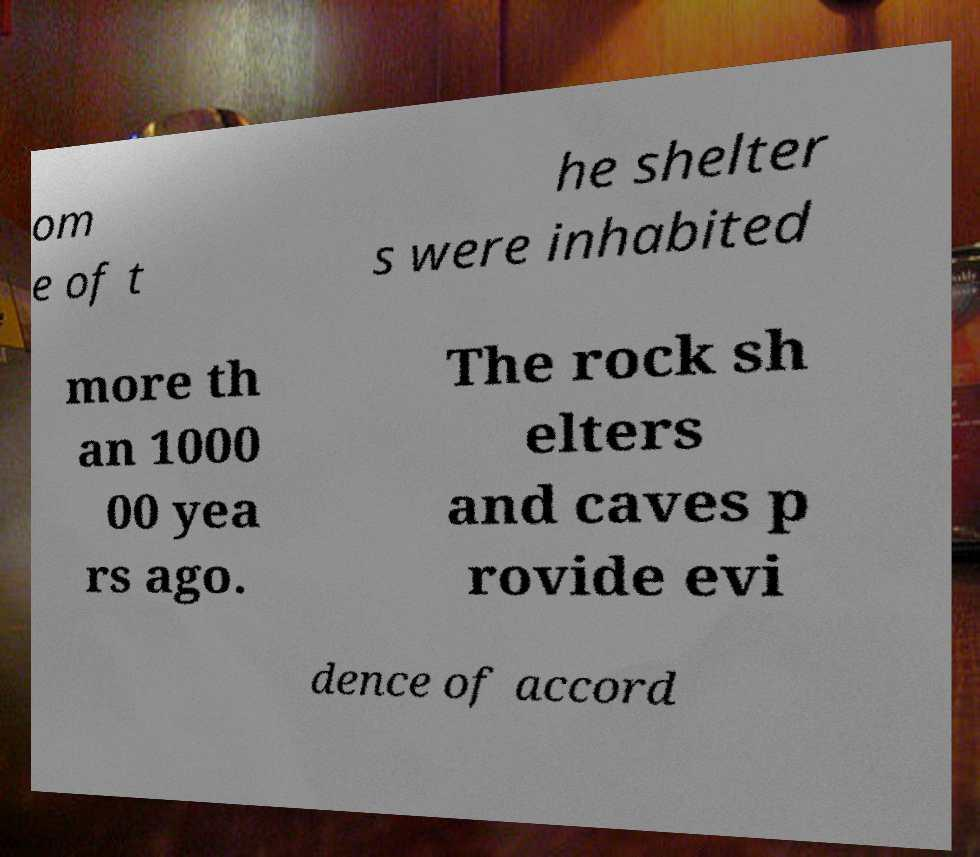I need the written content from this picture converted into text. Can you do that? om e of t he shelter s were inhabited more th an 1000 00 yea rs ago. The rock sh elters and caves p rovide evi dence of accord 